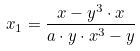<formula> <loc_0><loc_0><loc_500><loc_500>x _ { 1 } = \frac { x - y ^ { 3 } \cdot x } { a \cdot y \cdot x ^ { 3 } - y }</formula> 